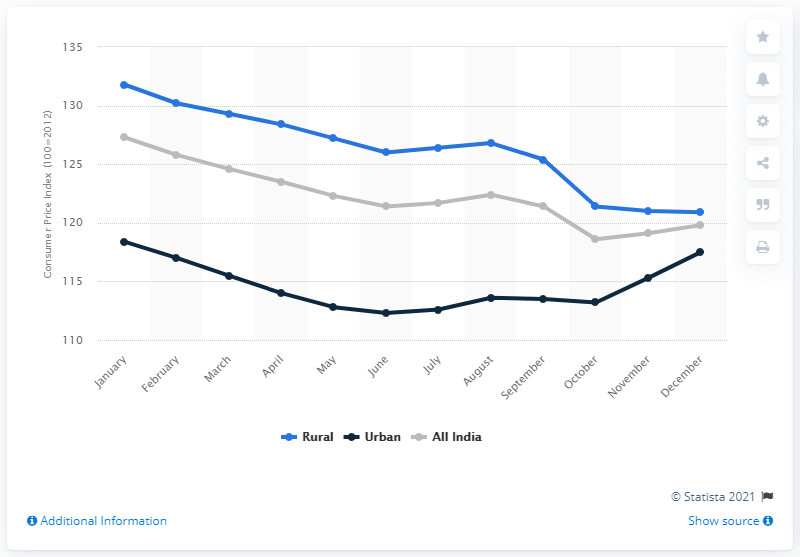Mention a couple of crucial points in this snapshot. In December 2018, the Consumer Price Index for pulses and its products in rural areas of India was 117.5. 